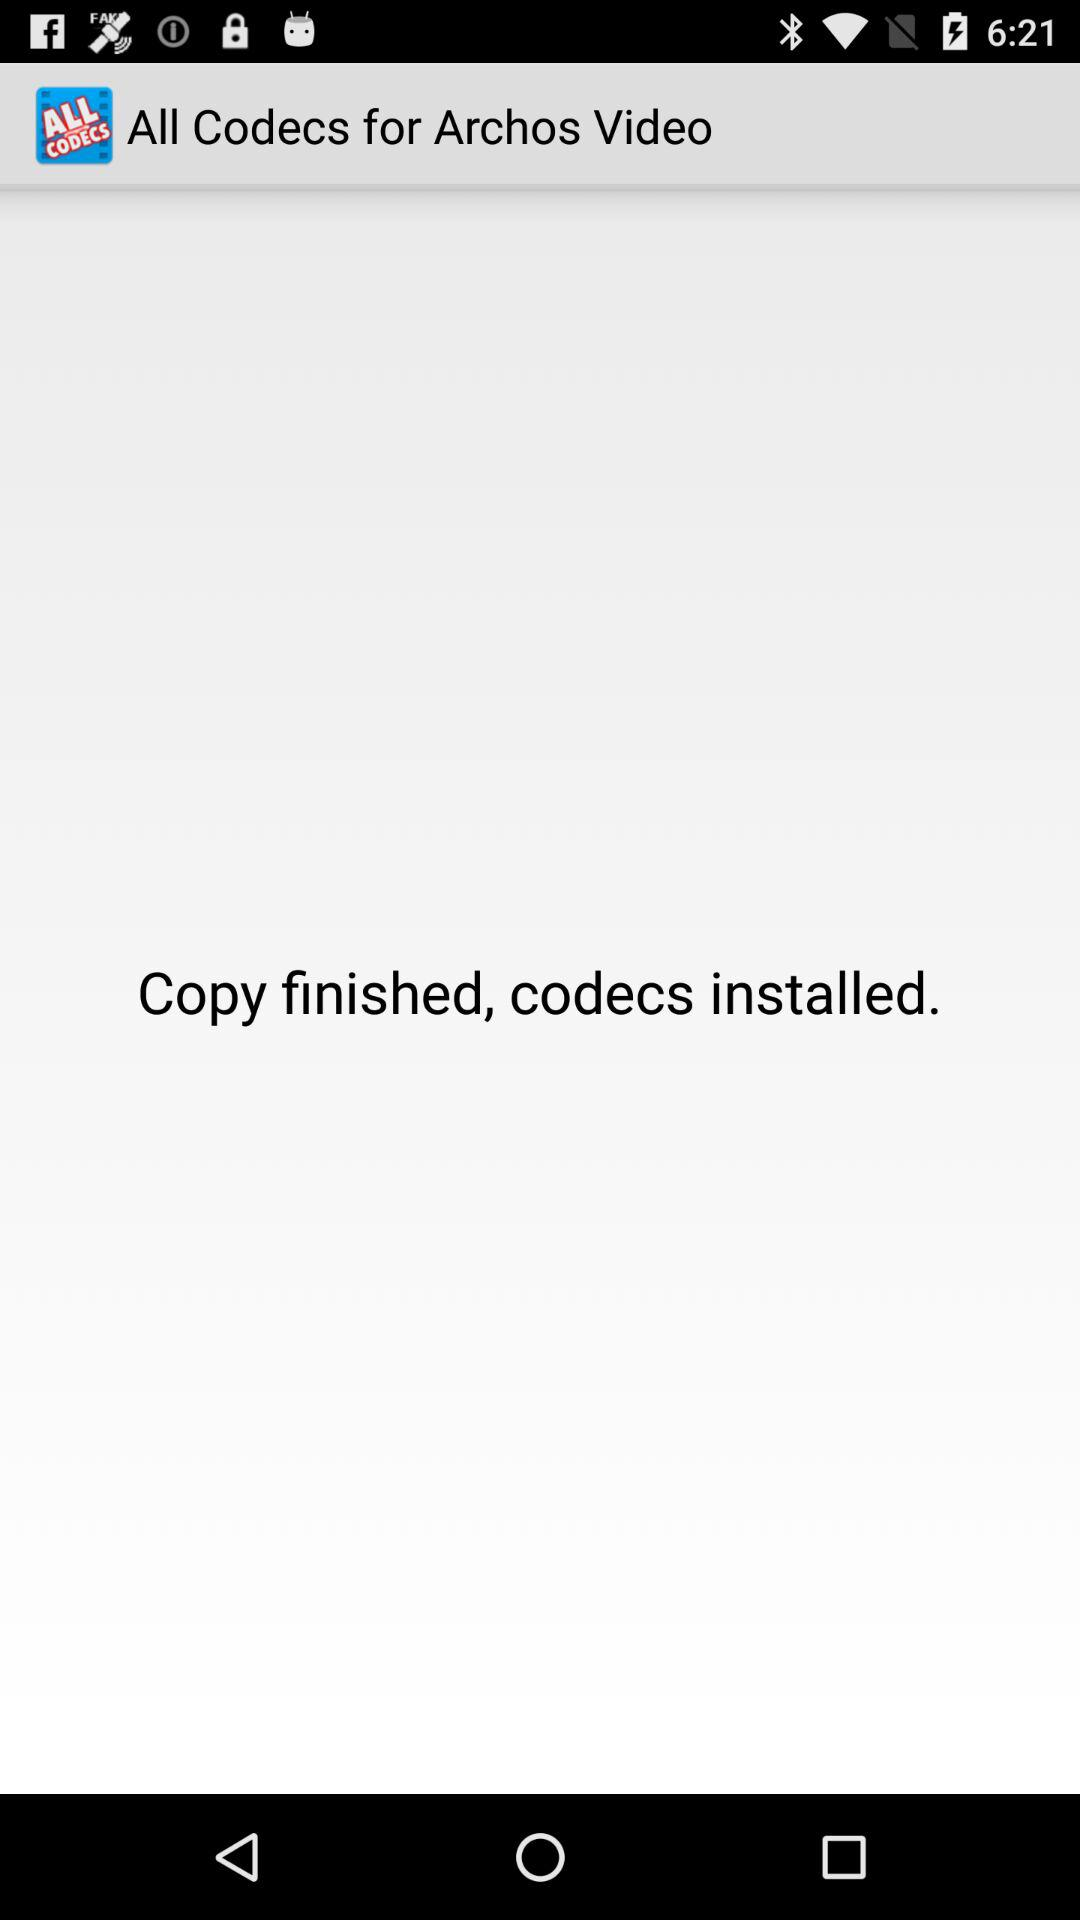What is the application name? The application name is "All Codecs for Archos Video". 